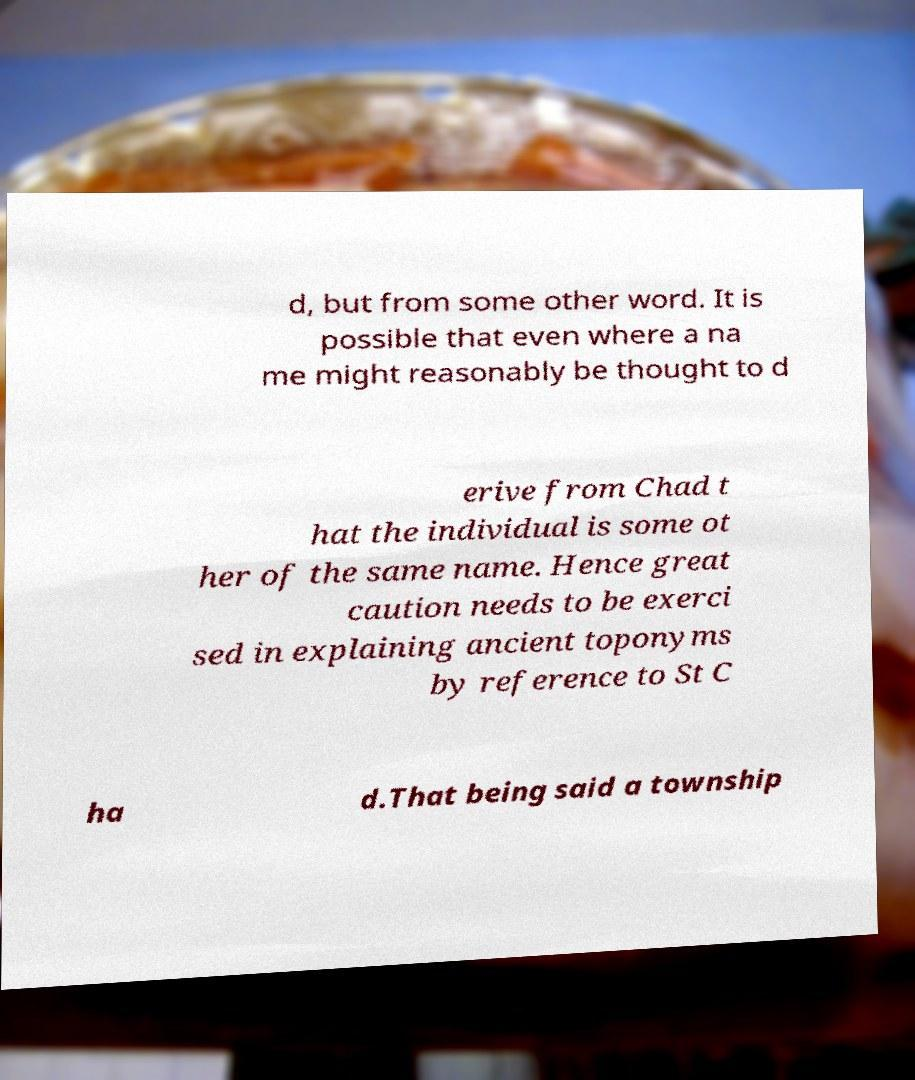Could you extract and type out the text from this image? d, but from some other word. It is possible that even where a na me might reasonably be thought to d erive from Chad t hat the individual is some ot her of the same name. Hence great caution needs to be exerci sed in explaining ancient toponyms by reference to St C ha d.That being said a township 